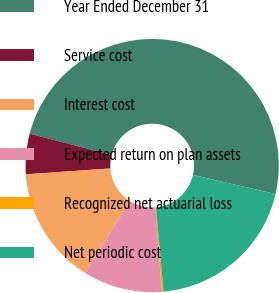Convert chart to OTSL. <chart><loc_0><loc_0><loc_500><loc_500><pie_chart><fcel>Year Ended December 31<fcel>Service cost<fcel>Interest cost<fcel>Expected return on plan assets<fcel>Recognized net actuarial loss<fcel>Net periodic cost<nl><fcel>49.56%<fcel>5.16%<fcel>15.02%<fcel>10.09%<fcel>0.22%<fcel>19.96%<nl></chart> 